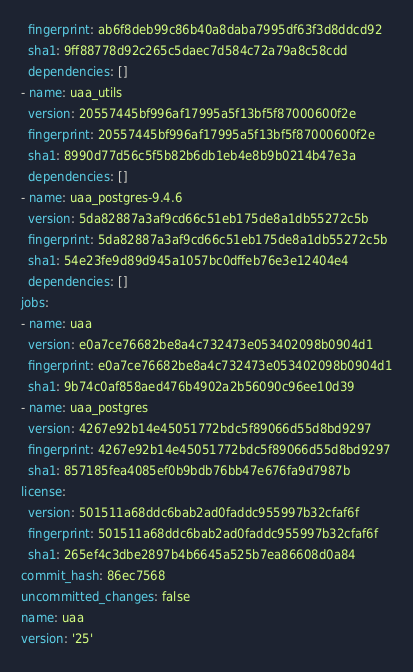Convert code to text. <code><loc_0><loc_0><loc_500><loc_500><_YAML_>  fingerprint: ab6f8deb99c86b40a8daba7995df63f3d8ddcd92
  sha1: 9ff88778d92c265c5daec7d584c72a79a8c58cdd
  dependencies: []
- name: uaa_utils
  version: 20557445bf996af17995a5f13bf5f87000600f2e
  fingerprint: 20557445bf996af17995a5f13bf5f87000600f2e
  sha1: 8990d77d56c5f5b82b6db1eb4e8b9b0214b47e3a
  dependencies: []
- name: uaa_postgres-9.4.6
  version: 5da82887a3af9cd66c51eb175de8a1db55272c5b
  fingerprint: 5da82887a3af9cd66c51eb175de8a1db55272c5b
  sha1: 54e23fe9d89d945a1057bc0dffeb76e3e12404e4
  dependencies: []
jobs:
- name: uaa
  version: e0a7ce76682be8a4c732473e053402098b0904d1
  fingerprint: e0a7ce76682be8a4c732473e053402098b0904d1
  sha1: 9b74c0af858aed476b4902a2b56090c96ee10d39
- name: uaa_postgres
  version: 4267e92b14e45051772bdc5f89066d55d8bd9297
  fingerprint: 4267e92b14e45051772bdc5f89066d55d8bd9297
  sha1: 857185fea4085ef0b9bdb76bb47e676fa9d7987b
license:
  version: 501511a68ddc6bab2ad0faddc955997b32cfaf6f
  fingerprint: 501511a68ddc6bab2ad0faddc955997b32cfaf6f
  sha1: 265ef4c3dbe2897b4b6645a525b7ea86608d0a84
commit_hash: 86ec7568
uncommitted_changes: false
name: uaa
version: '25'
</code> 